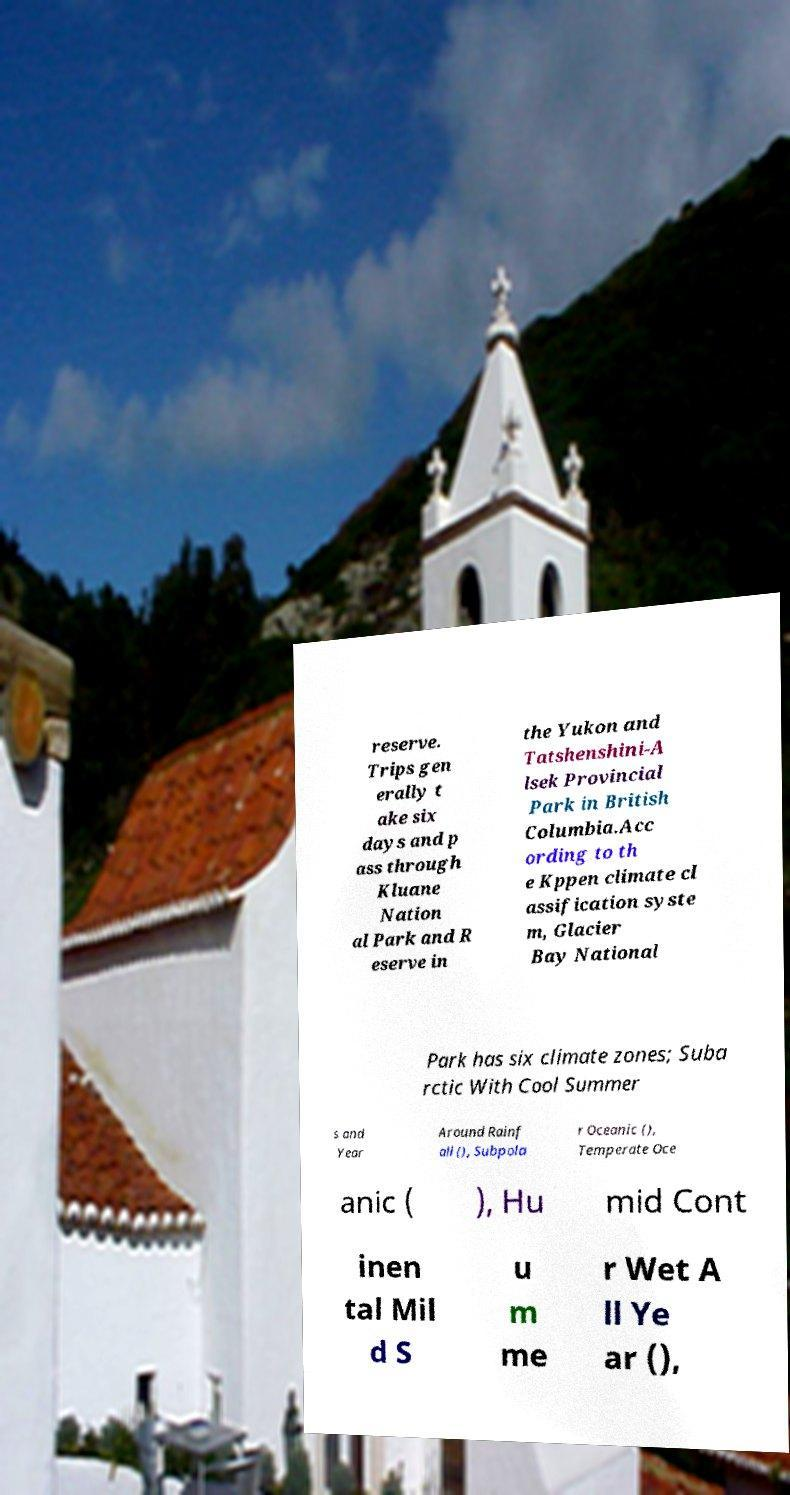There's text embedded in this image that I need extracted. Can you transcribe it verbatim? reserve. Trips gen erally t ake six days and p ass through Kluane Nation al Park and R eserve in the Yukon and Tatshenshini-A lsek Provincial Park in British Columbia.Acc ording to th e Kppen climate cl assification syste m, Glacier Bay National Park has six climate zones; Suba rctic With Cool Summer s and Year Around Rainf all (), Subpola r Oceanic (), Temperate Oce anic ( ), Hu mid Cont inen tal Mil d S u m me r Wet A ll Ye ar (), 